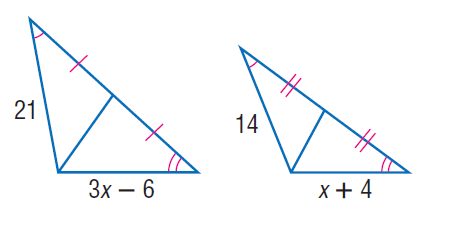Answer the mathemtical geometry problem and directly provide the correct option letter.
Question: Find x.
Choices: A: 6 B: 8 C: 10 D: 12 B 